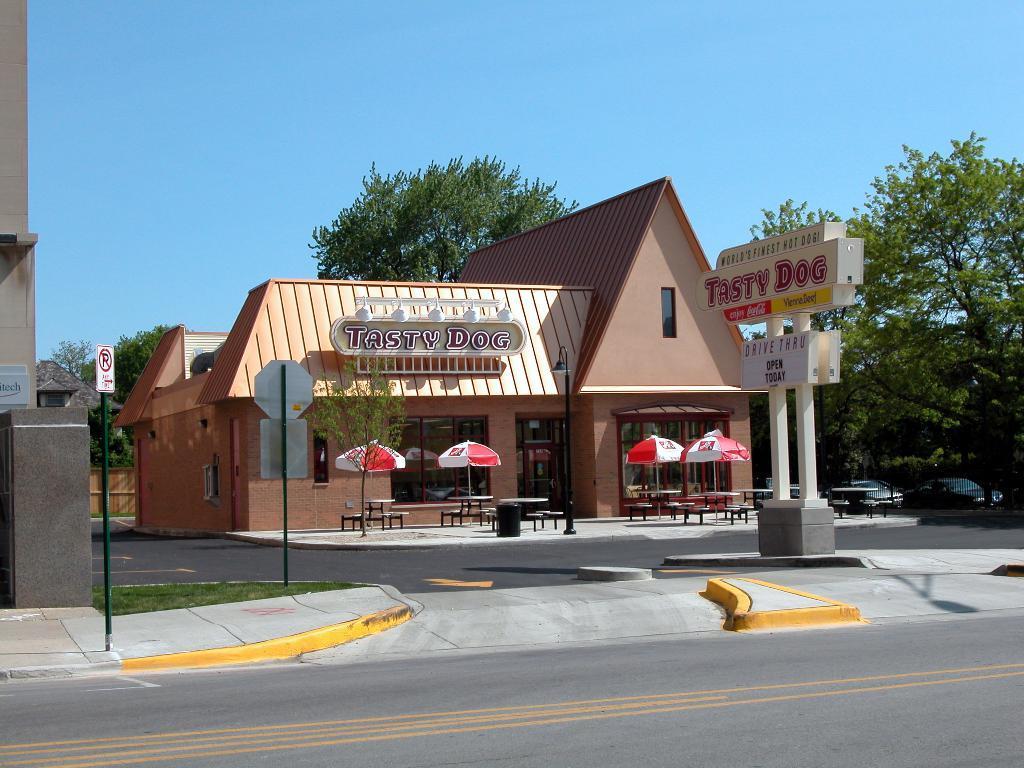How would you summarize this image in a sentence or two? In this image, we can see some houses. We can see the ground. We can also see some tables, chairs, umbrellas, trees. We can see some grass and the fence. We can also see some poles. Among them, we can see some poles with sign boards. We can also see the sky. We can also see some boards with text. 